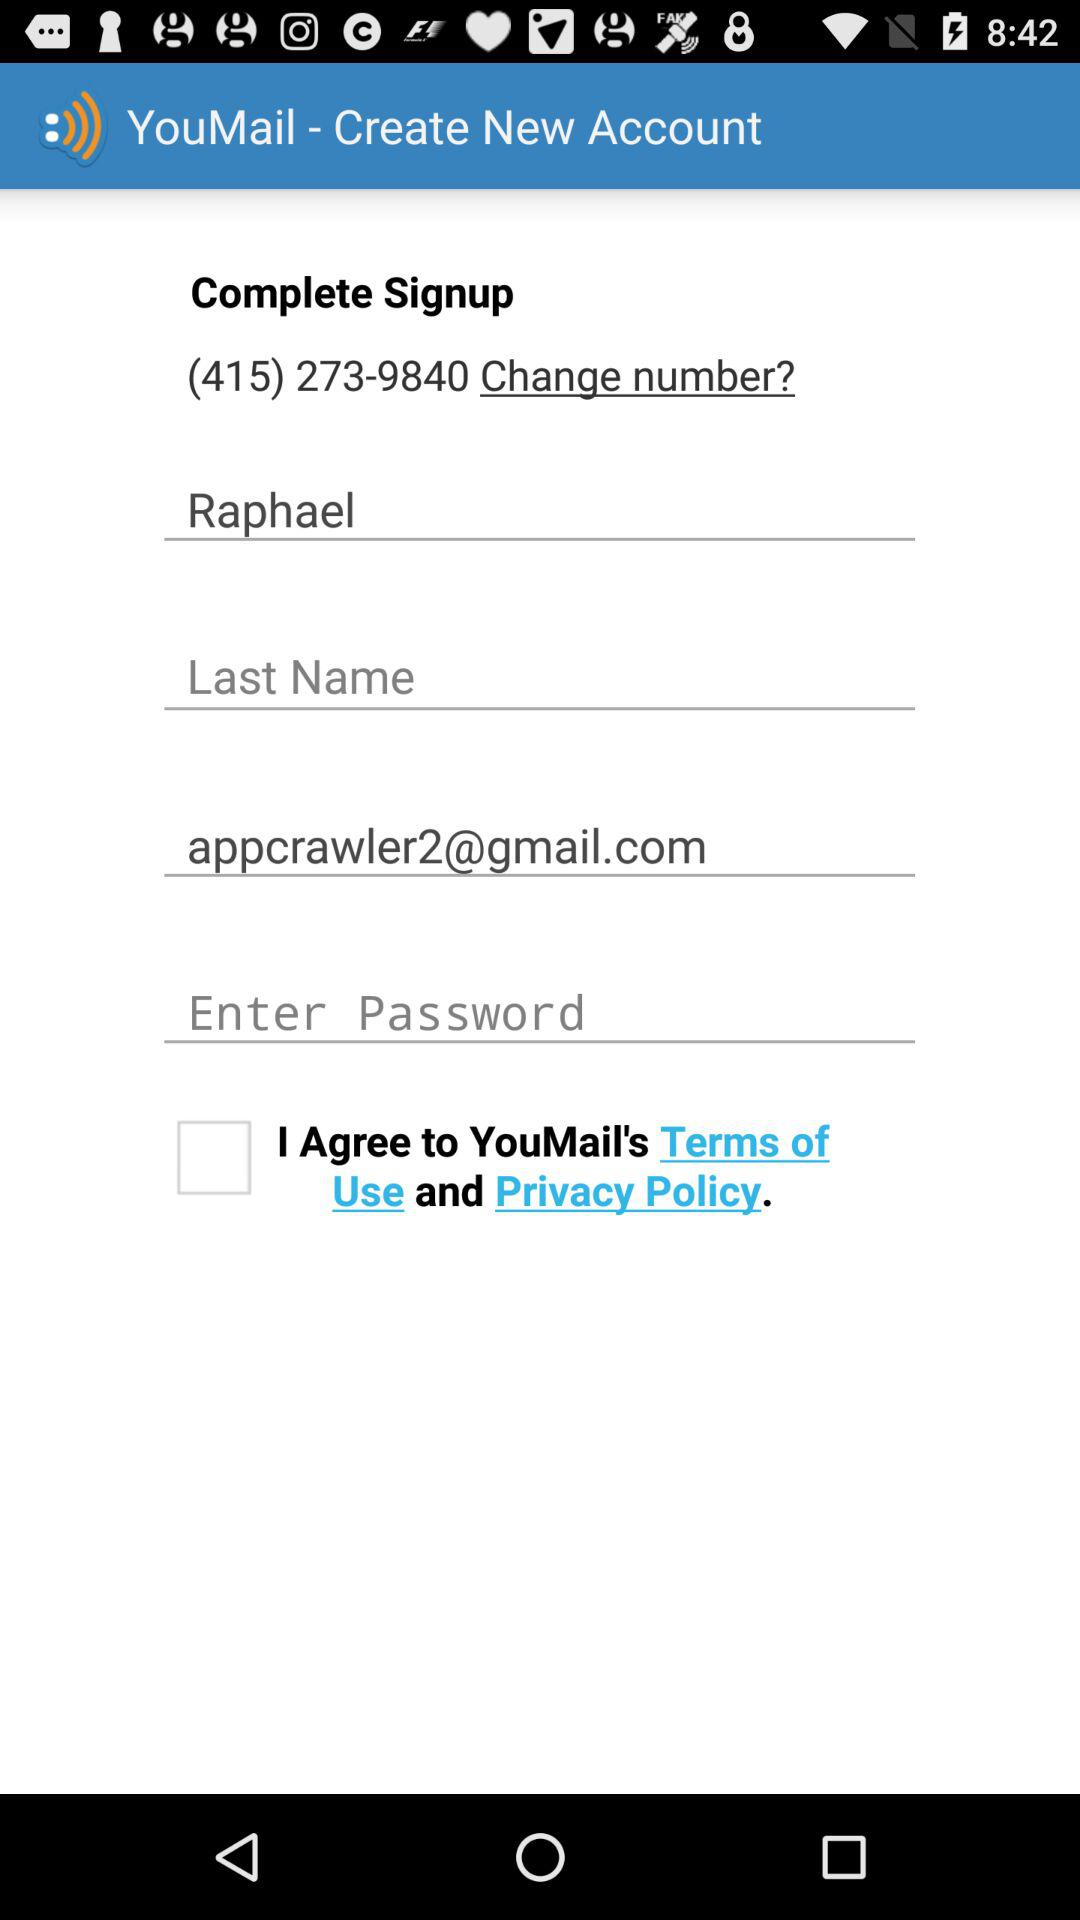What is the first name? The first name is Raphael. 